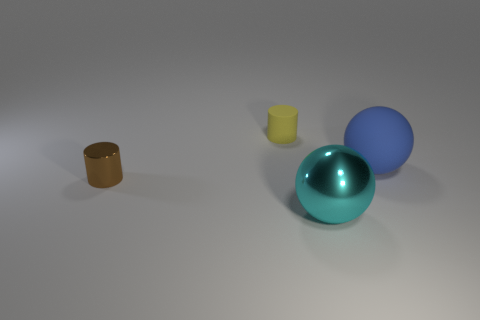What number of tiny objects are either green matte objects or brown things?
Your answer should be compact. 1. Are there any other things of the same color as the large metallic thing?
Give a very brief answer. No. What is the sphere behind the metallic object in front of the tiny brown metal cylinder that is left of the cyan thing made of?
Offer a terse response. Rubber. What number of metal things are big purple balls or large cyan spheres?
Your answer should be compact. 1. What number of gray objects are big rubber objects or tiny rubber cylinders?
Keep it short and to the point. 0. Is the material of the yellow thing the same as the large blue thing?
Your answer should be very brief. Yes. Is the number of brown things behind the large blue matte ball the same as the number of cyan metal objects in front of the shiny cylinder?
Offer a very short reply. No. There is another thing that is the same shape as the large metal thing; what is its material?
Ensure brevity in your answer.  Rubber. What shape is the big thing in front of the big blue matte sphere on the right side of the cylinder in front of the tiny yellow rubber cylinder?
Make the answer very short. Sphere. Is the number of small things that are on the left side of the yellow rubber thing greater than the number of small purple rubber balls?
Make the answer very short. Yes. 